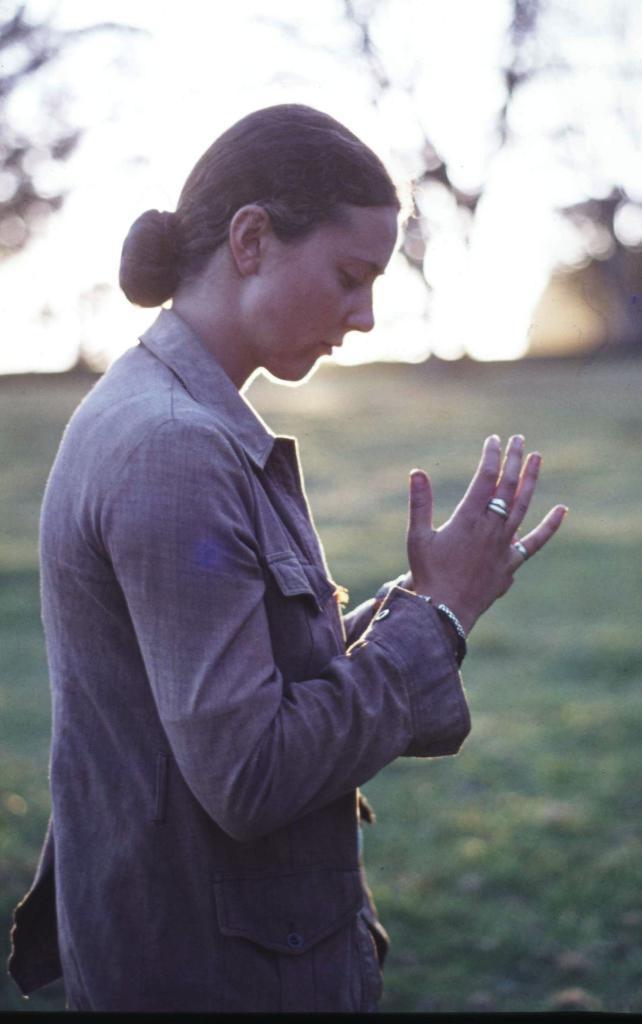Describe this image in one or two sentences. In this image we can see a woman. In the background there are sun rays falling. The background is blurred. 